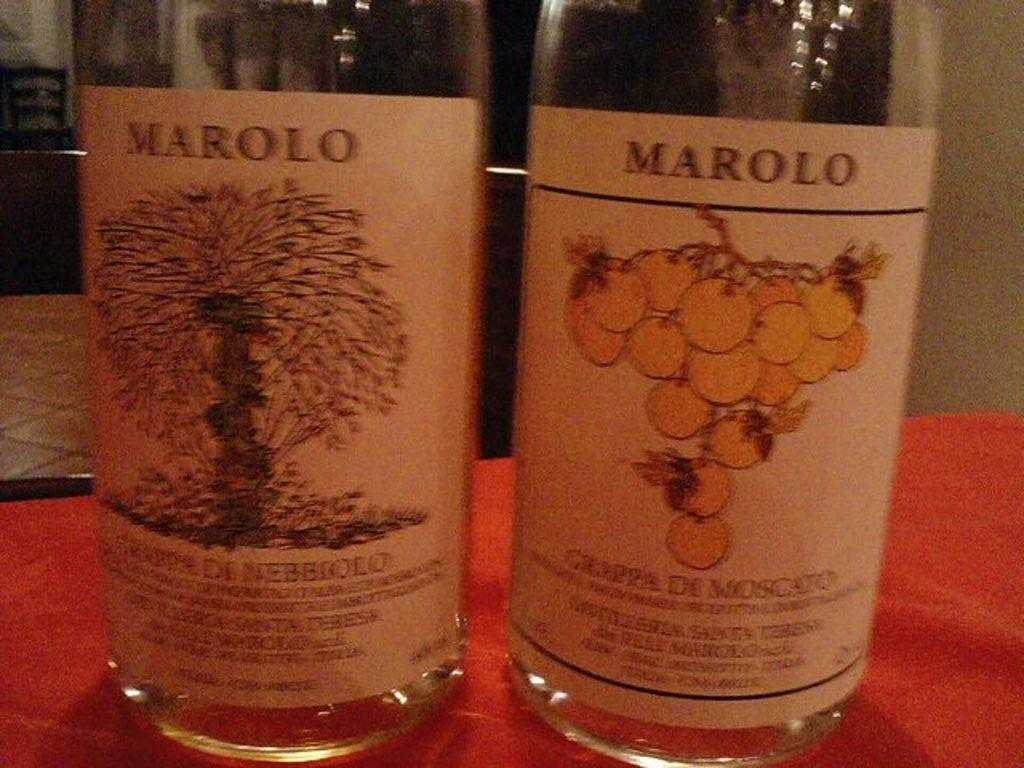<image>
Relay a brief, clear account of the picture shown. Two different varieties of Marolo brand wine site on a tablecloth covered table. 